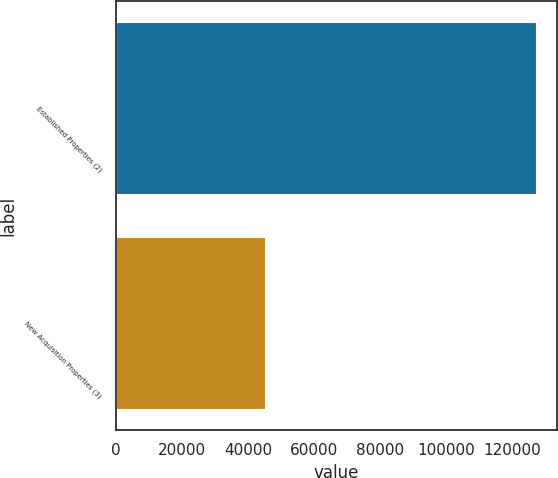Convert chart to OTSL. <chart><loc_0><loc_0><loc_500><loc_500><bar_chart><fcel>Established Properties (2)<fcel>New Acquisition Properties (3)<nl><fcel>127221<fcel>45048<nl></chart> 